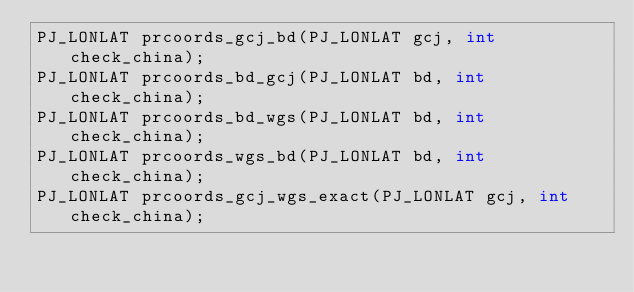<code> <loc_0><loc_0><loc_500><loc_500><_C_>PJ_LONLAT prcoords_gcj_bd(PJ_LONLAT gcj, int check_china);
PJ_LONLAT prcoords_bd_gcj(PJ_LONLAT bd, int check_china);
PJ_LONLAT prcoords_bd_wgs(PJ_LONLAT bd, int check_china);
PJ_LONLAT prcoords_wgs_bd(PJ_LONLAT bd, int check_china);
PJ_LONLAT prcoords_gcj_wgs_exact(PJ_LONLAT gcj, int check_china);</code> 